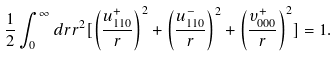<formula> <loc_0><loc_0><loc_500><loc_500>\frac { 1 } { 2 } \int _ { 0 } ^ { \infty } d r r ^ { 2 } [ \left ( \frac { u _ { 1 1 0 } ^ { + } } { r } \right ) ^ { 2 } + \left ( \frac { u _ { 1 1 0 } ^ { - } } { r } \right ) ^ { 2 } + \left ( \frac { \upsilon _ { 0 0 0 } ^ { + } } { r } \right ) ^ { 2 } ] = 1 .</formula> 